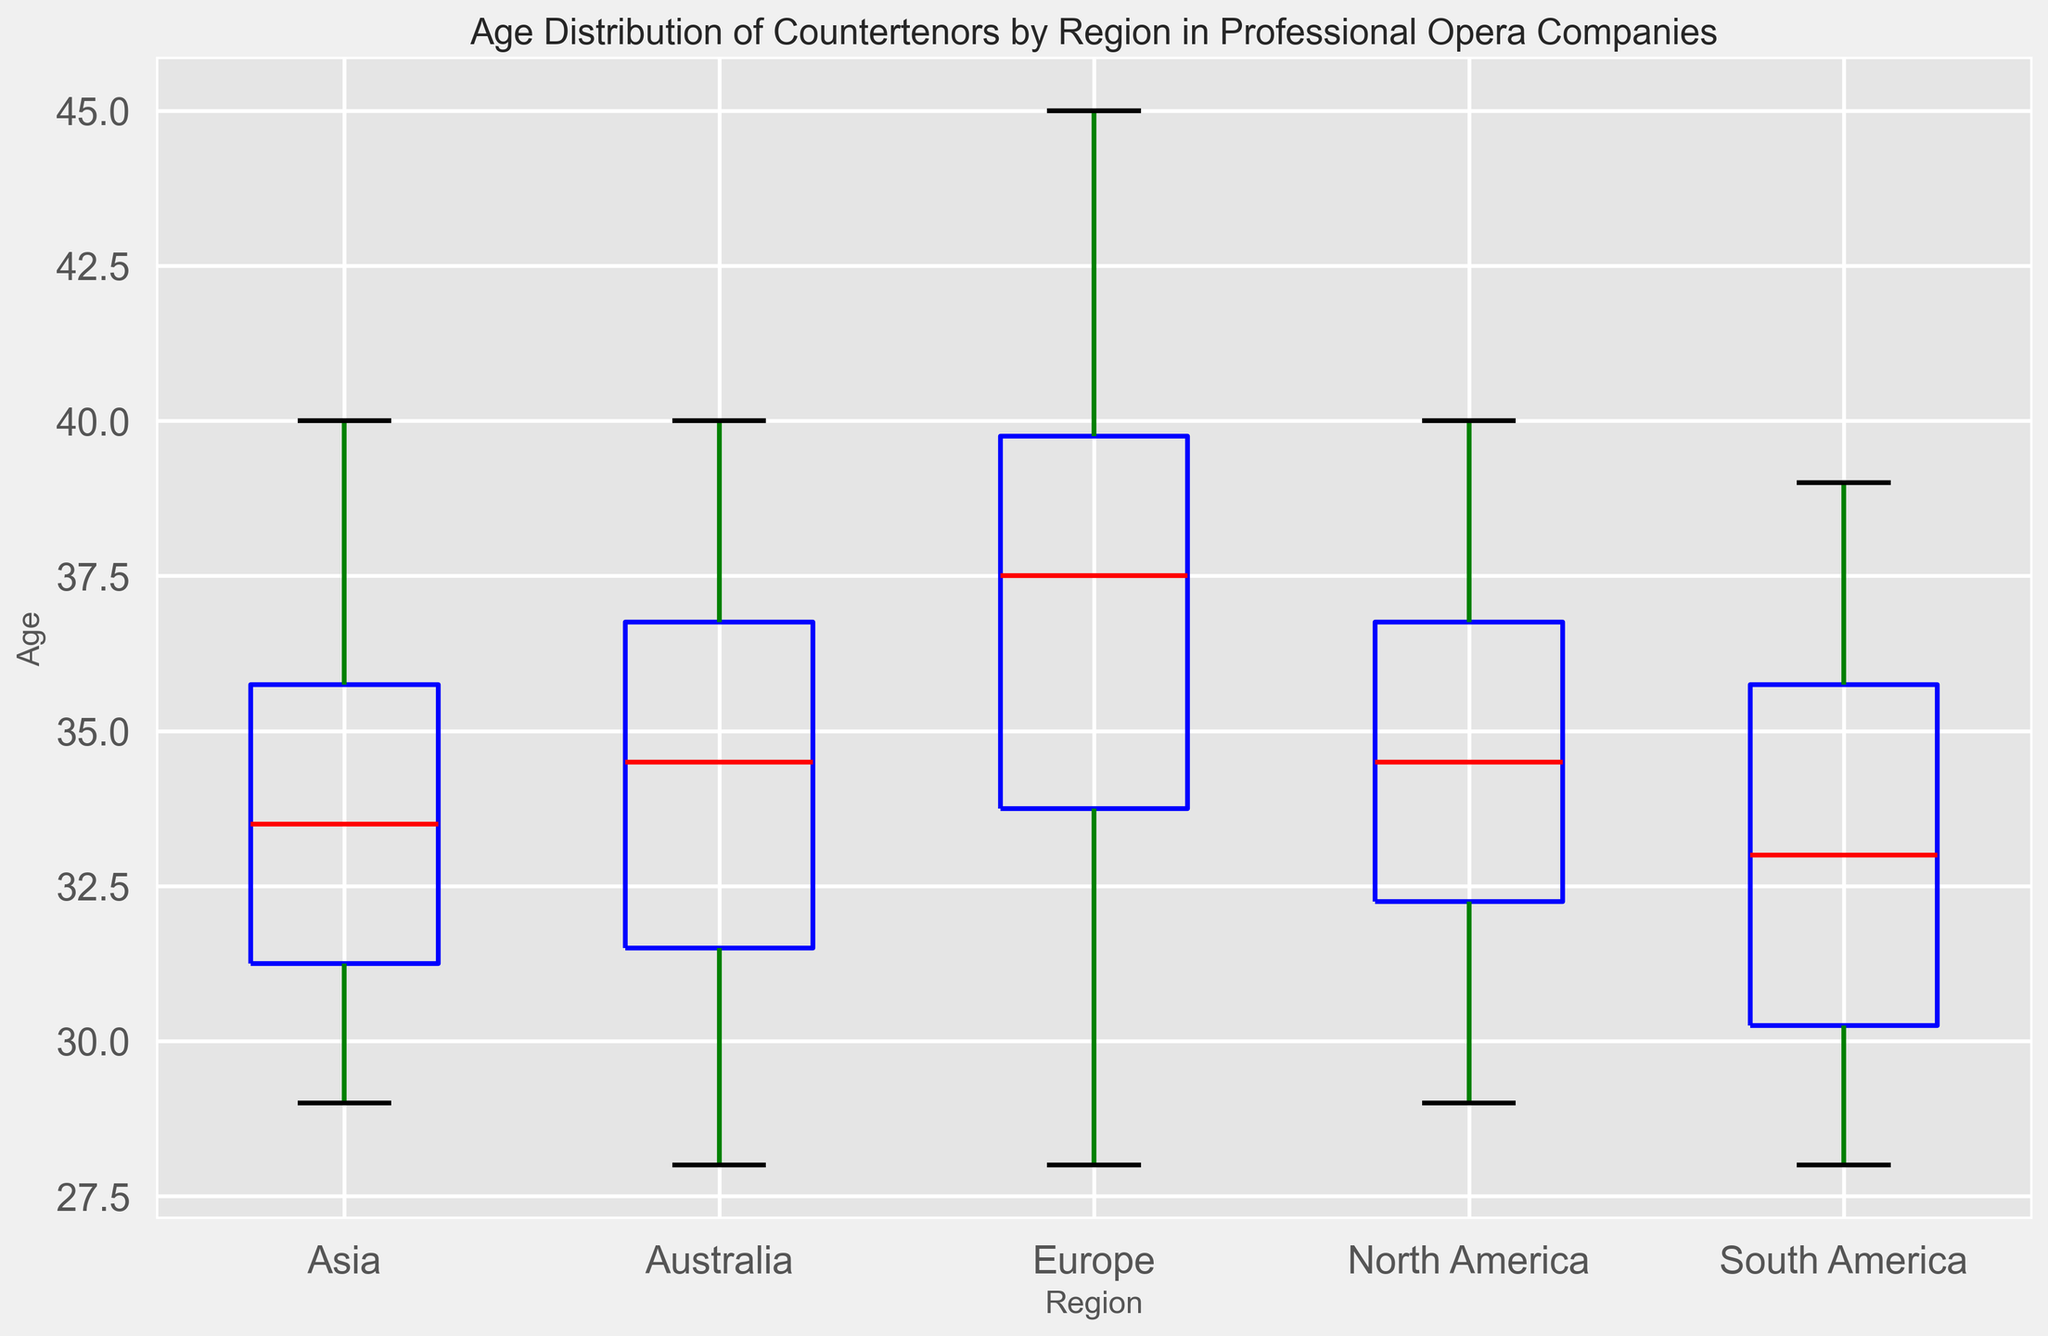What region has the highest median age for countertenors? To find the region with the highest median age, locate the median line (red) inside the box for each region and compare them. The median line for Australia is at 35, while the other regions have medians below this value.
Answer: Australia What is the interquartile range (IQR) for Age in North America? The IQR is the difference between the 75th percentile (top of the box) and the 25th percentile (bottom of the box). In North America, this is approximately between 37 and 32. So, IQR = 37 - 32 = 5.
Answer: 5 Which region has the widest age range for countertenors? The age range is identified by the distance between the top whisker and the bottom whisker. By comparing the whiskers' lengths across regions, Europe has the widest range, extending from 28 to 45 (a range of 17).
Answer: Europe Which region has the smallest variance in the age distribution of countertenors? Variance can be inferred by the spread of the box and whiskers. A smaller spread indicates lower variance. Asia has the narrowest box and whiskers spread relative to the other regions.
Answer: Asia Compare the median ages of countertenors in Europe and North America. Which is higher? Locate the red median lines for both regions in the boxes. Europe's median is at approximately 37, while North America's median is slightly lower at 35. Thus, Europe's median age is higher.
Answer: Europe What is the approximate age of the oldest countertenor in Asia? The oldest age is indicated by the topmost whisker in the box plot for Asia. This top whisker extends to around 40.
Answer: 40 Are there any regions with outliers in the age distribution of countertenors? Outliers are typically marked by individual points outside the whiskers in a box plot. None of the regions' box plots show individual points beyond the whiskers, indicating no outliers.
Answer: No What is the median age difference between the oldest and youngest regions? First, identify the medians: Australia's median is 35 (oldest), and South America's median is approximately 32 (youngest). The difference is 35 - 32 = 3.
Answer: 3 Which regions have overlapping interquartile ranges for age? Overlapping IQRs can be assessed by examining if the boxes for different regions overlap vertically. The IQRs for Europe, North America, and South America overlap significantly.
Answer: Europe, North America, South America Is there any region where the median age is below 30? The median age is indicated by the red line in each box. No region shows a median line below 30; all medians are above this value.
Answer: No 